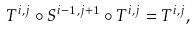<formula> <loc_0><loc_0><loc_500><loc_500>T ^ { i , j } \circ S ^ { i - 1 , j + 1 } \circ T ^ { i , j } = T ^ { i , j } ,</formula> 